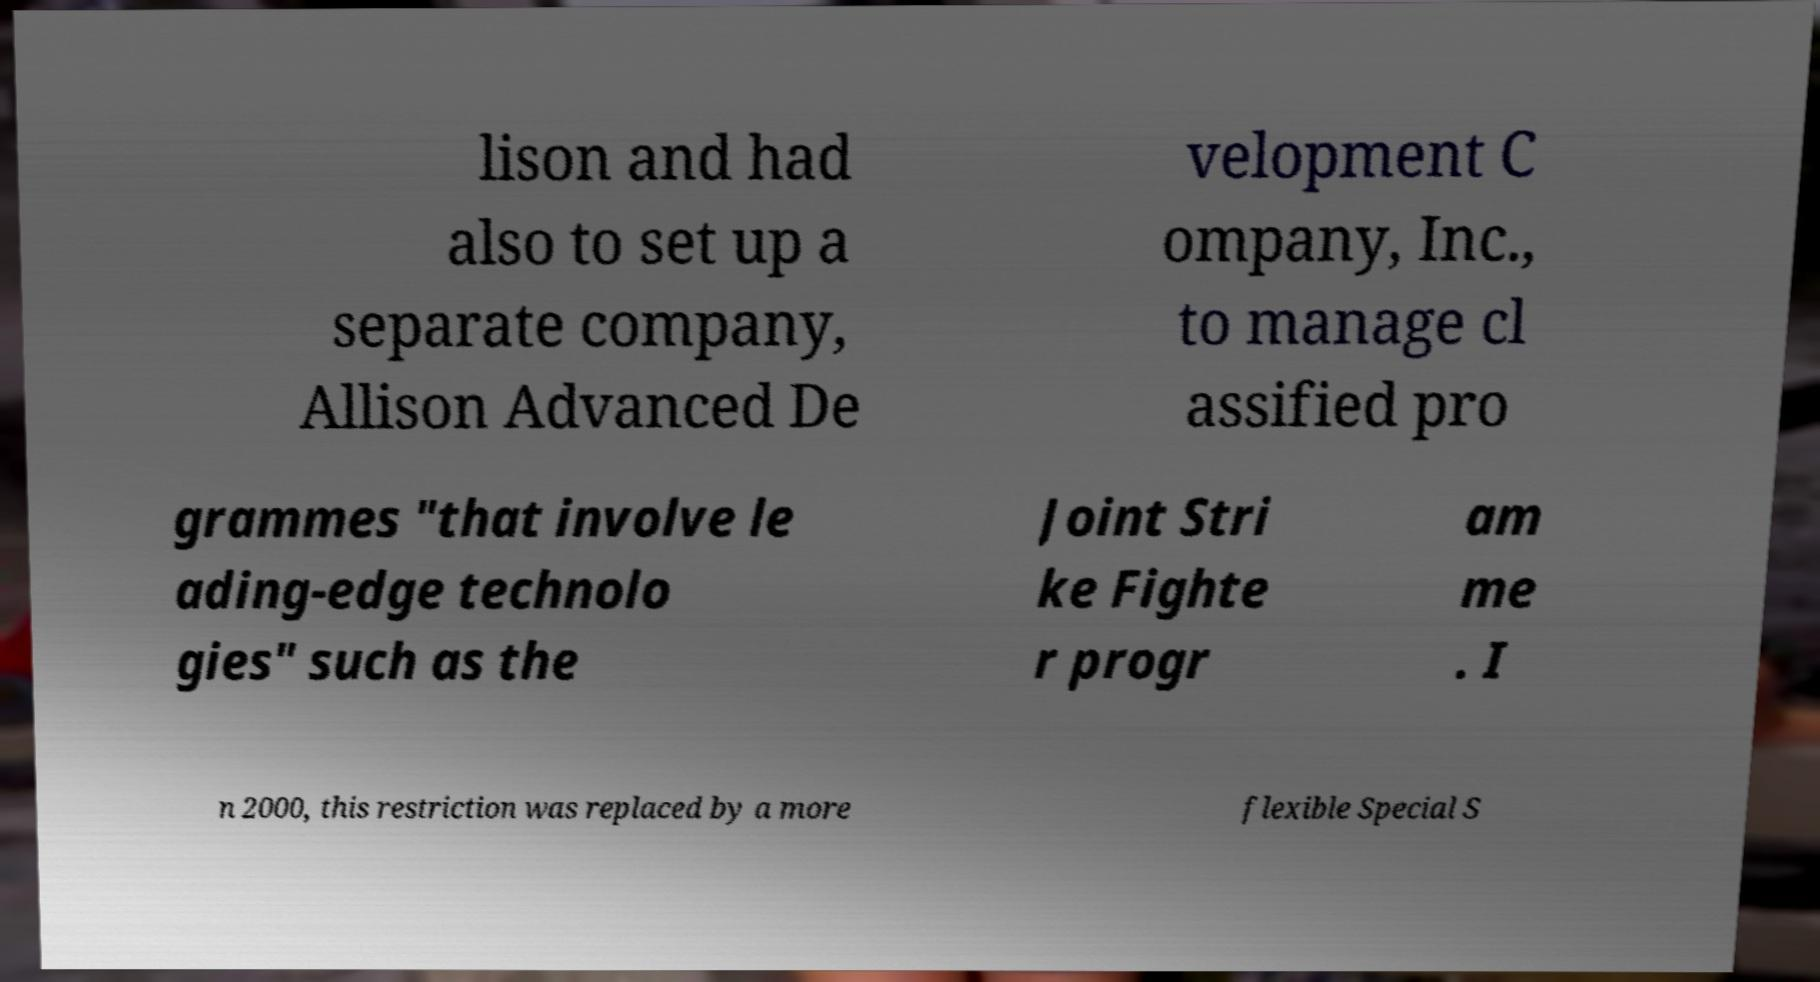Please identify and transcribe the text found in this image. lison and had also to set up a separate company, Allison Advanced De velopment C ompany, Inc., to manage cl assified pro grammes "that involve le ading-edge technolo gies" such as the Joint Stri ke Fighte r progr am me . I n 2000, this restriction was replaced by a more flexible Special S 